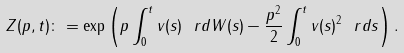<formula> <loc_0><loc_0><loc_500><loc_500>Z ( p , t ) \colon = \exp \left ( p \int _ { 0 } ^ { t } v ( s ) \ r d W ( s ) - \frac { p ^ { 2 } } { 2 } \int _ { 0 } ^ { t } v ( s ) ^ { 2 } \ r d s \right ) .</formula> 